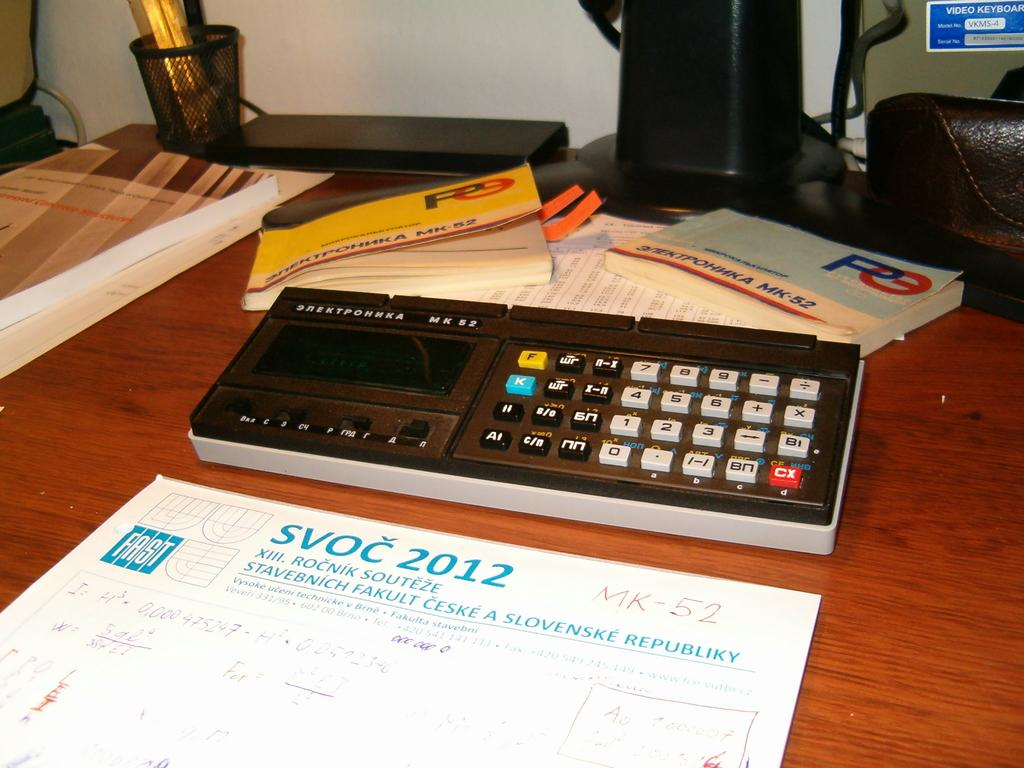<image>
Summarize the visual content of the image. A blue and white non-English deskpad with the letters SVOC 2012 